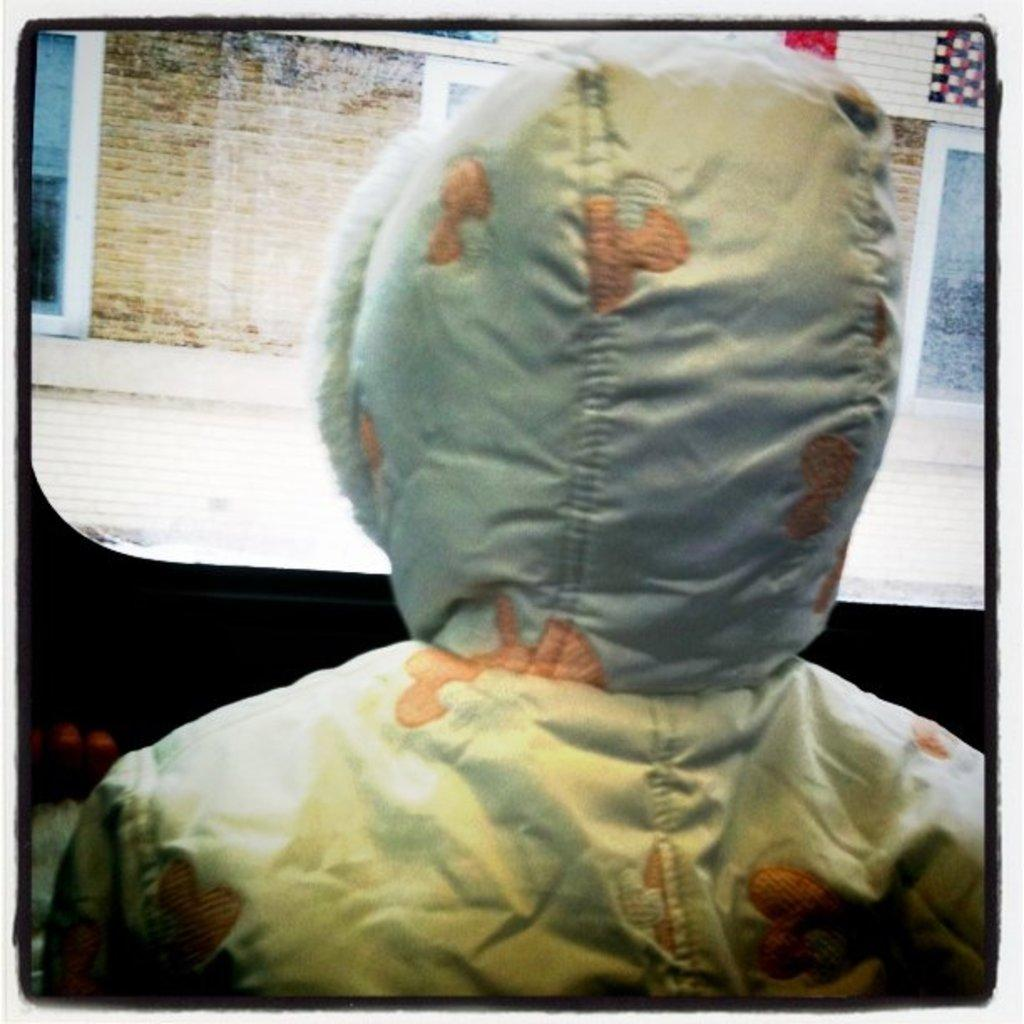What is the primary subject in the image? There is a person in the image. Can you describe the person's position or posture? The person is facing away from the viewer, providing a back view. What type of glass is the person holding in the image? There is no glass present in the image; the person is not holding anything. 